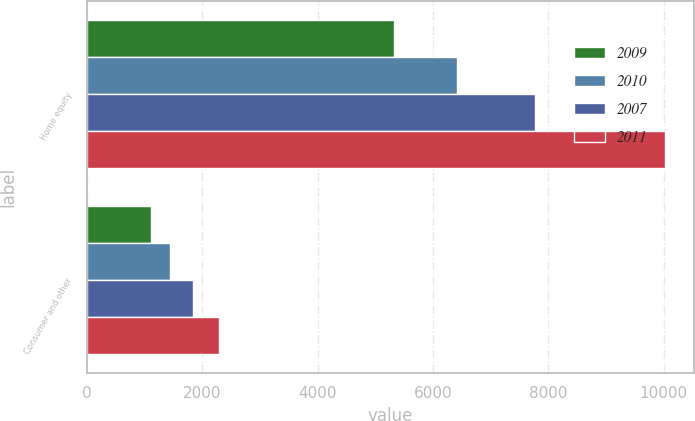Convert chart. <chart><loc_0><loc_0><loc_500><loc_500><stacked_bar_chart><ecel><fcel>Home equity<fcel>Consumer and other<nl><fcel>2009<fcel>5328.7<fcel>1113.2<nl><fcel>2010<fcel>6410.3<fcel>1443.4<nl><fcel>2007<fcel>7769.7<fcel>1841.3<nl><fcel>2011<fcel>10017.2<fcel>2298.6<nl></chart> 